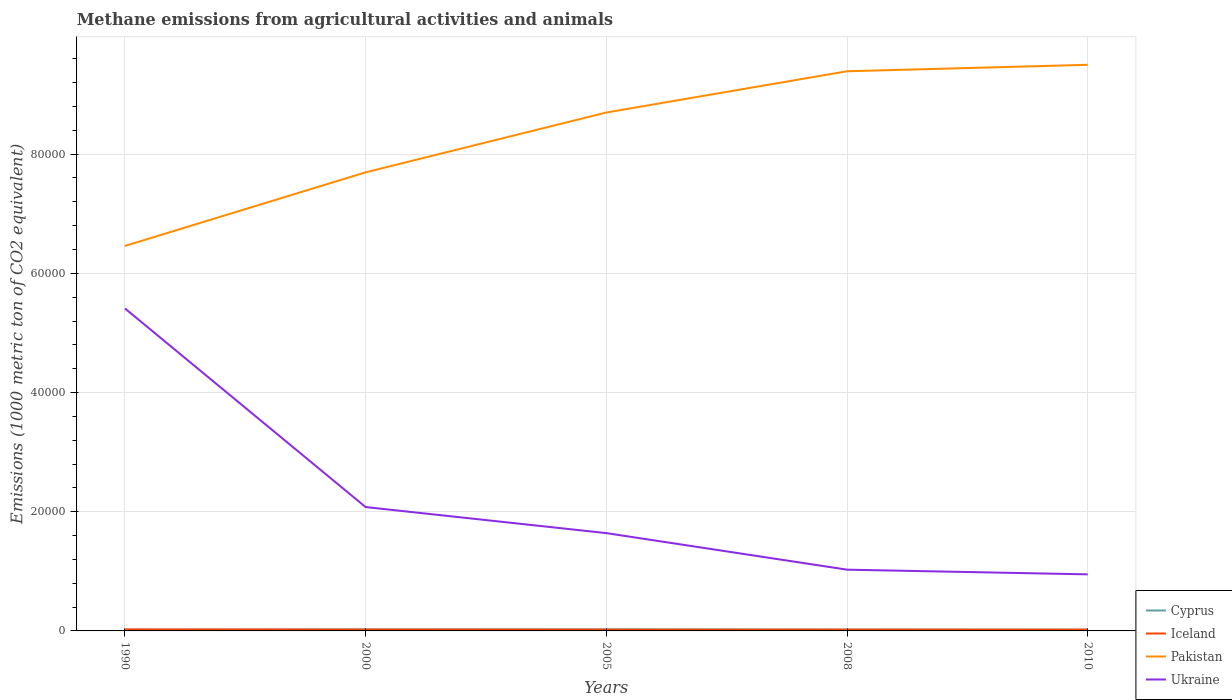How many different coloured lines are there?
Provide a succinct answer. 4. Does the line corresponding to Pakistan intersect with the line corresponding to Ukraine?
Offer a terse response. No. Is the number of lines equal to the number of legend labels?
Offer a terse response. Yes. Across all years, what is the maximum amount of methane emitted in Iceland?
Keep it short and to the point. 209.2. In which year was the amount of methane emitted in Cyprus maximum?
Offer a very short reply. 2010. What is the total amount of methane emitted in Ukraine in the graph?
Provide a short and direct response. 6921.6. What is the difference between the highest and the second highest amount of methane emitted in Iceland?
Your answer should be very brief. 36.1. What is the difference between the highest and the lowest amount of methane emitted in Cyprus?
Your response must be concise. 2. Is the amount of methane emitted in Pakistan strictly greater than the amount of methane emitted in Ukraine over the years?
Your response must be concise. No. What is the difference between two consecutive major ticks on the Y-axis?
Your response must be concise. 2.00e+04. Does the graph contain any zero values?
Ensure brevity in your answer.  No. Where does the legend appear in the graph?
Make the answer very short. Bottom right. How many legend labels are there?
Provide a succinct answer. 4. What is the title of the graph?
Your answer should be very brief. Methane emissions from agricultural activities and animals. What is the label or title of the X-axis?
Your answer should be very brief. Years. What is the label or title of the Y-axis?
Your response must be concise. Emissions (1000 metric ton of CO2 equivalent). What is the Emissions (1000 metric ton of CO2 equivalent) in Cyprus in 1990?
Offer a very short reply. 225.1. What is the Emissions (1000 metric ton of CO2 equivalent) in Iceland in 1990?
Your answer should be very brief. 245.3. What is the Emissions (1000 metric ton of CO2 equivalent) of Pakistan in 1990?
Ensure brevity in your answer.  6.46e+04. What is the Emissions (1000 metric ton of CO2 equivalent) in Ukraine in 1990?
Make the answer very short. 5.41e+04. What is the Emissions (1000 metric ton of CO2 equivalent) of Cyprus in 2000?
Ensure brevity in your answer.  261.7. What is the Emissions (1000 metric ton of CO2 equivalent) of Iceland in 2000?
Your response must be concise. 223.7. What is the Emissions (1000 metric ton of CO2 equivalent) of Pakistan in 2000?
Keep it short and to the point. 7.69e+04. What is the Emissions (1000 metric ton of CO2 equivalent) in Ukraine in 2000?
Provide a succinct answer. 2.08e+04. What is the Emissions (1000 metric ton of CO2 equivalent) of Cyprus in 2005?
Give a very brief answer. 271. What is the Emissions (1000 metric ton of CO2 equivalent) in Iceland in 2005?
Ensure brevity in your answer.  214.9. What is the Emissions (1000 metric ton of CO2 equivalent) of Pakistan in 2005?
Provide a succinct answer. 8.70e+04. What is the Emissions (1000 metric ton of CO2 equivalent) in Ukraine in 2005?
Your answer should be compact. 1.64e+04. What is the Emissions (1000 metric ton of CO2 equivalent) in Cyprus in 2008?
Offer a terse response. 231.7. What is the Emissions (1000 metric ton of CO2 equivalent) in Iceland in 2008?
Your response must be concise. 209.2. What is the Emissions (1000 metric ton of CO2 equivalent) of Pakistan in 2008?
Provide a short and direct response. 9.39e+04. What is the Emissions (1000 metric ton of CO2 equivalent) of Ukraine in 2008?
Your answer should be compact. 1.03e+04. What is the Emissions (1000 metric ton of CO2 equivalent) of Cyprus in 2010?
Offer a terse response. 217.6. What is the Emissions (1000 metric ton of CO2 equivalent) of Iceland in 2010?
Your answer should be compact. 212.4. What is the Emissions (1000 metric ton of CO2 equivalent) of Pakistan in 2010?
Offer a very short reply. 9.50e+04. What is the Emissions (1000 metric ton of CO2 equivalent) in Ukraine in 2010?
Your answer should be compact. 9489.8. Across all years, what is the maximum Emissions (1000 metric ton of CO2 equivalent) of Cyprus?
Provide a short and direct response. 271. Across all years, what is the maximum Emissions (1000 metric ton of CO2 equivalent) in Iceland?
Offer a very short reply. 245.3. Across all years, what is the maximum Emissions (1000 metric ton of CO2 equivalent) of Pakistan?
Offer a terse response. 9.50e+04. Across all years, what is the maximum Emissions (1000 metric ton of CO2 equivalent) of Ukraine?
Make the answer very short. 5.41e+04. Across all years, what is the minimum Emissions (1000 metric ton of CO2 equivalent) in Cyprus?
Your answer should be compact. 217.6. Across all years, what is the minimum Emissions (1000 metric ton of CO2 equivalent) in Iceland?
Make the answer very short. 209.2. Across all years, what is the minimum Emissions (1000 metric ton of CO2 equivalent) of Pakistan?
Make the answer very short. 6.46e+04. Across all years, what is the minimum Emissions (1000 metric ton of CO2 equivalent) of Ukraine?
Offer a very short reply. 9489.8. What is the total Emissions (1000 metric ton of CO2 equivalent) in Cyprus in the graph?
Your answer should be compact. 1207.1. What is the total Emissions (1000 metric ton of CO2 equivalent) in Iceland in the graph?
Give a very brief answer. 1105.5. What is the total Emissions (1000 metric ton of CO2 equivalent) of Pakistan in the graph?
Ensure brevity in your answer.  4.17e+05. What is the total Emissions (1000 metric ton of CO2 equivalent) of Ukraine in the graph?
Your answer should be very brief. 1.11e+05. What is the difference between the Emissions (1000 metric ton of CO2 equivalent) of Cyprus in 1990 and that in 2000?
Your answer should be compact. -36.6. What is the difference between the Emissions (1000 metric ton of CO2 equivalent) of Iceland in 1990 and that in 2000?
Offer a very short reply. 21.6. What is the difference between the Emissions (1000 metric ton of CO2 equivalent) in Pakistan in 1990 and that in 2000?
Provide a short and direct response. -1.24e+04. What is the difference between the Emissions (1000 metric ton of CO2 equivalent) in Ukraine in 1990 and that in 2000?
Offer a terse response. 3.33e+04. What is the difference between the Emissions (1000 metric ton of CO2 equivalent) of Cyprus in 1990 and that in 2005?
Offer a very short reply. -45.9. What is the difference between the Emissions (1000 metric ton of CO2 equivalent) in Iceland in 1990 and that in 2005?
Give a very brief answer. 30.4. What is the difference between the Emissions (1000 metric ton of CO2 equivalent) of Pakistan in 1990 and that in 2005?
Provide a short and direct response. -2.24e+04. What is the difference between the Emissions (1000 metric ton of CO2 equivalent) in Ukraine in 1990 and that in 2005?
Offer a very short reply. 3.77e+04. What is the difference between the Emissions (1000 metric ton of CO2 equivalent) of Cyprus in 1990 and that in 2008?
Offer a very short reply. -6.6. What is the difference between the Emissions (1000 metric ton of CO2 equivalent) in Iceland in 1990 and that in 2008?
Make the answer very short. 36.1. What is the difference between the Emissions (1000 metric ton of CO2 equivalent) of Pakistan in 1990 and that in 2008?
Provide a succinct answer. -2.93e+04. What is the difference between the Emissions (1000 metric ton of CO2 equivalent) of Ukraine in 1990 and that in 2008?
Keep it short and to the point. 4.38e+04. What is the difference between the Emissions (1000 metric ton of CO2 equivalent) in Iceland in 1990 and that in 2010?
Your response must be concise. 32.9. What is the difference between the Emissions (1000 metric ton of CO2 equivalent) in Pakistan in 1990 and that in 2010?
Provide a short and direct response. -3.04e+04. What is the difference between the Emissions (1000 metric ton of CO2 equivalent) of Ukraine in 1990 and that in 2010?
Offer a very short reply. 4.46e+04. What is the difference between the Emissions (1000 metric ton of CO2 equivalent) in Cyprus in 2000 and that in 2005?
Offer a terse response. -9.3. What is the difference between the Emissions (1000 metric ton of CO2 equivalent) of Iceland in 2000 and that in 2005?
Offer a very short reply. 8.8. What is the difference between the Emissions (1000 metric ton of CO2 equivalent) in Pakistan in 2000 and that in 2005?
Provide a short and direct response. -1.00e+04. What is the difference between the Emissions (1000 metric ton of CO2 equivalent) in Ukraine in 2000 and that in 2005?
Your answer should be very brief. 4372.1. What is the difference between the Emissions (1000 metric ton of CO2 equivalent) in Pakistan in 2000 and that in 2008?
Provide a succinct answer. -1.70e+04. What is the difference between the Emissions (1000 metric ton of CO2 equivalent) of Ukraine in 2000 and that in 2008?
Offer a terse response. 1.05e+04. What is the difference between the Emissions (1000 metric ton of CO2 equivalent) of Cyprus in 2000 and that in 2010?
Give a very brief answer. 44.1. What is the difference between the Emissions (1000 metric ton of CO2 equivalent) in Pakistan in 2000 and that in 2010?
Provide a short and direct response. -1.80e+04. What is the difference between the Emissions (1000 metric ton of CO2 equivalent) in Ukraine in 2000 and that in 2010?
Your answer should be compact. 1.13e+04. What is the difference between the Emissions (1000 metric ton of CO2 equivalent) of Cyprus in 2005 and that in 2008?
Keep it short and to the point. 39.3. What is the difference between the Emissions (1000 metric ton of CO2 equivalent) in Iceland in 2005 and that in 2008?
Offer a terse response. 5.7. What is the difference between the Emissions (1000 metric ton of CO2 equivalent) in Pakistan in 2005 and that in 2008?
Your answer should be compact. -6920.4. What is the difference between the Emissions (1000 metric ton of CO2 equivalent) of Ukraine in 2005 and that in 2008?
Your answer should be compact. 6133.4. What is the difference between the Emissions (1000 metric ton of CO2 equivalent) of Cyprus in 2005 and that in 2010?
Your answer should be very brief. 53.4. What is the difference between the Emissions (1000 metric ton of CO2 equivalent) in Iceland in 2005 and that in 2010?
Provide a short and direct response. 2.5. What is the difference between the Emissions (1000 metric ton of CO2 equivalent) of Pakistan in 2005 and that in 2010?
Give a very brief answer. -8002.4. What is the difference between the Emissions (1000 metric ton of CO2 equivalent) of Ukraine in 2005 and that in 2010?
Ensure brevity in your answer.  6921.6. What is the difference between the Emissions (1000 metric ton of CO2 equivalent) in Pakistan in 2008 and that in 2010?
Offer a very short reply. -1082. What is the difference between the Emissions (1000 metric ton of CO2 equivalent) of Ukraine in 2008 and that in 2010?
Offer a terse response. 788.2. What is the difference between the Emissions (1000 metric ton of CO2 equivalent) of Cyprus in 1990 and the Emissions (1000 metric ton of CO2 equivalent) of Pakistan in 2000?
Ensure brevity in your answer.  -7.67e+04. What is the difference between the Emissions (1000 metric ton of CO2 equivalent) of Cyprus in 1990 and the Emissions (1000 metric ton of CO2 equivalent) of Ukraine in 2000?
Offer a terse response. -2.06e+04. What is the difference between the Emissions (1000 metric ton of CO2 equivalent) in Iceland in 1990 and the Emissions (1000 metric ton of CO2 equivalent) in Pakistan in 2000?
Your answer should be compact. -7.67e+04. What is the difference between the Emissions (1000 metric ton of CO2 equivalent) in Iceland in 1990 and the Emissions (1000 metric ton of CO2 equivalent) in Ukraine in 2000?
Your answer should be compact. -2.05e+04. What is the difference between the Emissions (1000 metric ton of CO2 equivalent) in Pakistan in 1990 and the Emissions (1000 metric ton of CO2 equivalent) in Ukraine in 2000?
Give a very brief answer. 4.38e+04. What is the difference between the Emissions (1000 metric ton of CO2 equivalent) of Cyprus in 1990 and the Emissions (1000 metric ton of CO2 equivalent) of Pakistan in 2005?
Offer a very short reply. -8.68e+04. What is the difference between the Emissions (1000 metric ton of CO2 equivalent) of Cyprus in 1990 and the Emissions (1000 metric ton of CO2 equivalent) of Ukraine in 2005?
Your answer should be very brief. -1.62e+04. What is the difference between the Emissions (1000 metric ton of CO2 equivalent) of Iceland in 1990 and the Emissions (1000 metric ton of CO2 equivalent) of Pakistan in 2005?
Provide a short and direct response. -8.67e+04. What is the difference between the Emissions (1000 metric ton of CO2 equivalent) of Iceland in 1990 and the Emissions (1000 metric ton of CO2 equivalent) of Ukraine in 2005?
Give a very brief answer. -1.62e+04. What is the difference between the Emissions (1000 metric ton of CO2 equivalent) of Pakistan in 1990 and the Emissions (1000 metric ton of CO2 equivalent) of Ukraine in 2005?
Give a very brief answer. 4.82e+04. What is the difference between the Emissions (1000 metric ton of CO2 equivalent) in Cyprus in 1990 and the Emissions (1000 metric ton of CO2 equivalent) in Pakistan in 2008?
Your answer should be compact. -9.37e+04. What is the difference between the Emissions (1000 metric ton of CO2 equivalent) of Cyprus in 1990 and the Emissions (1000 metric ton of CO2 equivalent) of Ukraine in 2008?
Provide a succinct answer. -1.01e+04. What is the difference between the Emissions (1000 metric ton of CO2 equivalent) of Iceland in 1990 and the Emissions (1000 metric ton of CO2 equivalent) of Pakistan in 2008?
Your response must be concise. -9.37e+04. What is the difference between the Emissions (1000 metric ton of CO2 equivalent) in Iceland in 1990 and the Emissions (1000 metric ton of CO2 equivalent) in Ukraine in 2008?
Keep it short and to the point. -1.00e+04. What is the difference between the Emissions (1000 metric ton of CO2 equivalent) of Pakistan in 1990 and the Emissions (1000 metric ton of CO2 equivalent) of Ukraine in 2008?
Ensure brevity in your answer.  5.43e+04. What is the difference between the Emissions (1000 metric ton of CO2 equivalent) of Cyprus in 1990 and the Emissions (1000 metric ton of CO2 equivalent) of Iceland in 2010?
Your response must be concise. 12.7. What is the difference between the Emissions (1000 metric ton of CO2 equivalent) in Cyprus in 1990 and the Emissions (1000 metric ton of CO2 equivalent) in Pakistan in 2010?
Keep it short and to the point. -9.48e+04. What is the difference between the Emissions (1000 metric ton of CO2 equivalent) of Cyprus in 1990 and the Emissions (1000 metric ton of CO2 equivalent) of Ukraine in 2010?
Your response must be concise. -9264.7. What is the difference between the Emissions (1000 metric ton of CO2 equivalent) of Iceland in 1990 and the Emissions (1000 metric ton of CO2 equivalent) of Pakistan in 2010?
Make the answer very short. -9.47e+04. What is the difference between the Emissions (1000 metric ton of CO2 equivalent) in Iceland in 1990 and the Emissions (1000 metric ton of CO2 equivalent) in Ukraine in 2010?
Keep it short and to the point. -9244.5. What is the difference between the Emissions (1000 metric ton of CO2 equivalent) in Pakistan in 1990 and the Emissions (1000 metric ton of CO2 equivalent) in Ukraine in 2010?
Your answer should be very brief. 5.51e+04. What is the difference between the Emissions (1000 metric ton of CO2 equivalent) in Cyprus in 2000 and the Emissions (1000 metric ton of CO2 equivalent) in Iceland in 2005?
Provide a short and direct response. 46.8. What is the difference between the Emissions (1000 metric ton of CO2 equivalent) in Cyprus in 2000 and the Emissions (1000 metric ton of CO2 equivalent) in Pakistan in 2005?
Offer a terse response. -8.67e+04. What is the difference between the Emissions (1000 metric ton of CO2 equivalent) of Cyprus in 2000 and the Emissions (1000 metric ton of CO2 equivalent) of Ukraine in 2005?
Provide a succinct answer. -1.61e+04. What is the difference between the Emissions (1000 metric ton of CO2 equivalent) of Iceland in 2000 and the Emissions (1000 metric ton of CO2 equivalent) of Pakistan in 2005?
Keep it short and to the point. -8.68e+04. What is the difference between the Emissions (1000 metric ton of CO2 equivalent) in Iceland in 2000 and the Emissions (1000 metric ton of CO2 equivalent) in Ukraine in 2005?
Provide a succinct answer. -1.62e+04. What is the difference between the Emissions (1000 metric ton of CO2 equivalent) of Pakistan in 2000 and the Emissions (1000 metric ton of CO2 equivalent) of Ukraine in 2005?
Give a very brief answer. 6.05e+04. What is the difference between the Emissions (1000 metric ton of CO2 equivalent) of Cyprus in 2000 and the Emissions (1000 metric ton of CO2 equivalent) of Iceland in 2008?
Offer a very short reply. 52.5. What is the difference between the Emissions (1000 metric ton of CO2 equivalent) in Cyprus in 2000 and the Emissions (1000 metric ton of CO2 equivalent) in Pakistan in 2008?
Keep it short and to the point. -9.36e+04. What is the difference between the Emissions (1000 metric ton of CO2 equivalent) in Cyprus in 2000 and the Emissions (1000 metric ton of CO2 equivalent) in Ukraine in 2008?
Offer a very short reply. -1.00e+04. What is the difference between the Emissions (1000 metric ton of CO2 equivalent) of Iceland in 2000 and the Emissions (1000 metric ton of CO2 equivalent) of Pakistan in 2008?
Your answer should be compact. -9.37e+04. What is the difference between the Emissions (1000 metric ton of CO2 equivalent) of Iceland in 2000 and the Emissions (1000 metric ton of CO2 equivalent) of Ukraine in 2008?
Your answer should be compact. -1.01e+04. What is the difference between the Emissions (1000 metric ton of CO2 equivalent) of Pakistan in 2000 and the Emissions (1000 metric ton of CO2 equivalent) of Ukraine in 2008?
Keep it short and to the point. 6.67e+04. What is the difference between the Emissions (1000 metric ton of CO2 equivalent) of Cyprus in 2000 and the Emissions (1000 metric ton of CO2 equivalent) of Iceland in 2010?
Your answer should be compact. 49.3. What is the difference between the Emissions (1000 metric ton of CO2 equivalent) in Cyprus in 2000 and the Emissions (1000 metric ton of CO2 equivalent) in Pakistan in 2010?
Keep it short and to the point. -9.47e+04. What is the difference between the Emissions (1000 metric ton of CO2 equivalent) in Cyprus in 2000 and the Emissions (1000 metric ton of CO2 equivalent) in Ukraine in 2010?
Your answer should be compact. -9228.1. What is the difference between the Emissions (1000 metric ton of CO2 equivalent) in Iceland in 2000 and the Emissions (1000 metric ton of CO2 equivalent) in Pakistan in 2010?
Keep it short and to the point. -9.48e+04. What is the difference between the Emissions (1000 metric ton of CO2 equivalent) in Iceland in 2000 and the Emissions (1000 metric ton of CO2 equivalent) in Ukraine in 2010?
Provide a succinct answer. -9266.1. What is the difference between the Emissions (1000 metric ton of CO2 equivalent) of Pakistan in 2000 and the Emissions (1000 metric ton of CO2 equivalent) of Ukraine in 2010?
Your answer should be compact. 6.75e+04. What is the difference between the Emissions (1000 metric ton of CO2 equivalent) of Cyprus in 2005 and the Emissions (1000 metric ton of CO2 equivalent) of Iceland in 2008?
Offer a terse response. 61.8. What is the difference between the Emissions (1000 metric ton of CO2 equivalent) in Cyprus in 2005 and the Emissions (1000 metric ton of CO2 equivalent) in Pakistan in 2008?
Your response must be concise. -9.36e+04. What is the difference between the Emissions (1000 metric ton of CO2 equivalent) in Cyprus in 2005 and the Emissions (1000 metric ton of CO2 equivalent) in Ukraine in 2008?
Your answer should be compact. -1.00e+04. What is the difference between the Emissions (1000 metric ton of CO2 equivalent) of Iceland in 2005 and the Emissions (1000 metric ton of CO2 equivalent) of Pakistan in 2008?
Keep it short and to the point. -9.37e+04. What is the difference between the Emissions (1000 metric ton of CO2 equivalent) of Iceland in 2005 and the Emissions (1000 metric ton of CO2 equivalent) of Ukraine in 2008?
Provide a short and direct response. -1.01e+04. What is the difference between the Emissions (1000 metric ton of CO2 equivalent) of Pakistan in 2005 and the Emissions (1000 metric ton of CO2 equivalent) of Ukraine in 2008?
Offer a very short reply. 7.67e+04. What is the difference between the Emissions (1000 metric ton of CO2 equivalent) of Cyprus in 2005 and the Emissions (1000 metric ton of CO2 equivalent) of Iceland in 2010?
Your response must be concise. 58.6. What is the difference between the Emissions (1000 metric ton of CO2 equivalent) of Cyprus in 2005 and the Emissions (1000 metric ton of CO2 equivalent) of Pakistan in 2010?
Offer a terse response. -9.47e+04. What is the difference between the Emissions (1000 metric ton of CO2 equivalent) in Cyprus in 2005 and the Emissions (1000 metric ton of CO2 equivalent) in Ukraine in 2010?
Your answer should be very brief. -9218.8. What is the difference between the Emissions (1000 metric ton of CO2 equivalent) in Iceland in 2005 and the Emissions (1000 metric ton of CO2 equivalent) in Pakistan in 2010?
Provide a succinct answer. -9.48e+04. What is the difference between the Emissions (1000 metric ton of CO2 equivalent) in Iceland in 2005 and the Emissions (1000 metric ton of CO2 equivalent) in Ukraine in 2010?
Your response must be concise. -9274.9. What is the difference between the Emissions (1000 metric ton of CO2 equivalent) in Pakistan in 2005 and the Emissions (1000 metric ton of CO2 equivalent) in Ukraine in 2010?
Offer a terse response. 7.75e+04. What is the difference between the Emissions (1000 metric ton of CO2 equivalent) of Cyprus in 2008 and the Emissions (1000 metric ton of CO2 equivalent) of Iceland in 2010?
Keep it short and to the point. 19.3. What is the difference between the Emissions (1000 metric ton of CO2 equivalent) of Cyprus in 2008 and the Emissions (1000 metric ton of CO2 equivalent) of Pakistan in 2010?
Keep it short and to the point. -9.48e+04. What is the difference between the Emissions (1000 metric ton of CO2 equivalent) of Cyprus in 2008 and the Emissions (1000 metric ton of CO2 equivalent) of Ukraine in 2010?
Provide a short and direct response. -9258.1. What is the difference between the Emissions (1000 metric ton of CO2 equivalent) in Iceland in 2008 and the Emissions (1000 metric ton of CO2 equivalent) in Pakistan in 2010?
Offer a terse response. -9.48e+04. What is the difference between the Emissions (1000 metric ton of CO2 equivalent) of Iceland in 2008 and the Emissions (1000 metric ton of CO2 equivalent) of Ukraine in 2010?
Ensure brevity in your answer.  -9280.6. What is the difference between the Emissions (1000 metric ton of CO2 equivalent) in Pakistan in 2008 and the Emissions (1000 metric ton of CO2 equivalent) in Ukraine in 2010?
Give a very brief answer. 8.44e+04. What is the average Emissions (1000 metric ton of CO2 equivalent) of Cyprus per year?
Ensure brevity in your answer.  241.42. What is the average Emissions (1000 metric ton of CO2 equivalent) in Iceland per year?
Provide a short and direct response. 221.1. What is the average Emissions (1000 metric ton of CO2 equivalent) of Pakistan per year?
Offer a terse response. 8.35e+04. What is the average Emissions (1000 metric ton of CO2 equivalent) of Ukraine per year?
Your response must be concise. 2.22e+04. In the year 1990, what is the difference between the Emissions (1000 metric ton of CO2 equivalent) of Cyprus and Emissions (1000 metric ton of CO2 equivalent) of Iceland?
Your answer should be very brief. -20.2. In the year 1990, what is the difference between the Emissions (1000 metric ton of CO2 equivalent) in Cyprus and Emissions (1000 metric ton of CO2 equivalent) in Pakistan?
Offer a very short reply. -6.44e+04. In the year 1990, what is the difference between the Emissions (1000 metric ton of CO2 equivalent) of Cyprus and Emissions (1000 metric ton of CO2 equivalent) of Ukraine?
Keep it short and to the point. -5.39e+04. In the year 1990, what is the difference between the Emissions (1000 metric ton of CO2 equivalent) in Iceland and Emissions (1000 metric ton of CO2 equivalent) in Pakistan?
Your answer should be very brief. -6.43e+04. In the year 1990, what is the difference between the Emissions (1000 metric ton of CO2 equivalent) of Iceland and Emissions (1000 metric ton of CO2 equivalent) of Ukraine?
Give a very brief answer. -5.39e+04. In the year 1990, what is the difference between the Emissions (1000 metric ton of CO2 equivalent) of Pakistan and Emissions (1000 metric ton of CO2 equivalent) of Ukraine?
Provide a short and direct response. 1.05e+04. In the year 2000, what is the difference between the Emissions (1000 metric ton of CO2 equivalent) of Cyprus and Emissions (1000 metric ton of CO2 equivalent) of Pakistan?
Ensure brevity in your answer.  -7.67e+04. In the year 2000, what is the difference between the Emissions (1000 metric ton of CO2 equivalent) of Cyprus and Emissions (1000 metric ton of CO2 equivalent) of Ukraine?
Provide a short and direct response. -2.05e+04. In the year 2000, what is the difference between the Emissions (1000 metric ton of CO2 equivalent) of Iceland and Emissions (1000 metric ton of CO2 equivalent) of Pakistan?
Offer a terse response. -7.67e+04. In the year 2000, what is the difference between the Emissions (1000 metric ton of CO2 equivalent) of Iceland and Emissions (1000 metric ton of CO2 equivalent) of Ukraine?
Offer a terse response. -2.06e+04. In the year 2000, what is the difference between the Emissions (1000 metric ton of CO2 equivalent) in Pakistan and Emissions (1000 metric ton of CO2 equivalent) in Ukraine?
Keep it short and to the point. 5.62e+04. In the year 2005, what is the difference between the Emissions (1000 metric ton of CO2 equivalent) in Cyprus and Emissions (1000 metric ton of CO2 equivalent) in Iceland?
Give a very brief answer. 56.1. In the year 2005, what is the difference between the Emissions (1000 metric ton of CO2 equivalent) of Cyprus and Emissions (1000 metric ton of CO2 equivalent) of Pakistan?
Ensure brevity in your answer.  -8.67e+04. In the year 2005, what is the difference between the Emissions (1000 metric ton of CO2 equivalent) in Cyprus and Emissions (1000 metric ton of CO2 equivalent) in Ukraine?
Provide a succinct answer. -1.61e+04. In the year 2005, what is the difference between the Emissions (1000 metric ton of CO2 equivalent) of Iceland and Emissions (1000 metric ton of CO2 equivalent) of Pakistan?
Ensure brevity in your answer.  -8.68e+04. In the year 2005, what is the difference between the Emissions (1000 metric ton of CO2 equivalent) in Iceland and Emissions (1000 metric ton of CO2 equivalent) in Ukraine?
Your response must be concise. -1.62e+04. In the year 2005, what is the difference between the Emissions (1000 metric ton of CO2 equivalent) in Pakistan and Emissions (1000 metric ton of CO2 equivalent) in Ukraine?
Make the answer very short. 7.06e+04. In the year 2008, what is the difference between the Emissions (1000 metric ton of CO2 equivalent) of Cyprus and Emissions (1000 metric ton of CO2 equivalent) of Pakistan?
Keep it short and to the point. -9.37e+04. In the year 2008, what is the difference between the Emissions (1000 metric ton of CO2 equivalent) of Cyprus and Emissions (1000 metric ton of CO2 equivalent) of Ukraine?
Keep it short and to the point. -1.00e+04. In the year 2008, what is the difference between the Emissions (1000 metric ton of CO2 equivalent) of Iceland and Emissions (1000 metric ton of CO2 equivalent) of Pakistan?
Offer a very short reply. -9.37e+04. In the year 2008, what is the difference between the Emissions (1000 metric ton of CO2 equivalent) of Iceland and Emissions (1000 metric ton of CO2 equivalent) of Ukraine?
Make the answer very short. -1.01e+04. In the year 2008, what is the difference between the Emissions (1000 metric ton of CO2 equivalent) in Pakistan and Emissions (1000 metric ton of CO2 equivalent) in Ukraine?
Make the answer very short. 8.36e+04. In the year 2010, what is the difference between the Emissions (1000 metric ton of CO2 equivalent) of Cyprus and Emissions (1000 metric ton of CO2 equivalent) of Pakistan?
Your answer should be compact. -9.48e+04. In the year 2010, what is the difference between the Emissions (1000 metric ton of CO2 equivalent) of Cyprus and Emissions (1000 metric ton of CO2 equivalent) of Ukraine?
Provide a short and direct response. -9272.2. In the year 2010, what is the difference between the Emissions (1000 metric ton of CO2 equivalent) of Iceland and Emissions (1000 metric ton of CO2 equivalent) of Pakistan?
Provide a succinct answer. -9.48e+04. In the year 2010, what is the difference between the Emissions (1000 metric ton of CO2 equivalent) in Iceland and Emissions (1000 metric ton of CO2 equivalent) in Ukraine?
Ensure brevity in your answer.  -9277.4. In the year 2010, what is the difference between the Emissions (1000 metric ton of CO2 equivalent) of Pakistan and Emissions (1000 metric ton of CO2 equivalent) of Ukraine?
Offer a terse response. 8.55e+04. What is the ratio of the Emissions (1000 metric ton of CO2 equivalent) of Cyprus in 1990 to that in 2000?
Keep it short and to the point. 0.86. What is the ratio of the Emissions (1000 metric ton of CO2 equivalent) in Iceland in 1990 to that in 2000?
Give a very brief answer. 1.1. What is the ratio of the Emissions (1000 metric ton of CO2 equivalent) in Pakistan in 1990 to that in 2000?
Your answer should be very brief. 0.84. What is the ratio of the Emissions (1000 metric ton of CO2 equivalent) of Ukraine in 1990 to that in 2000?
Keep it short and to the point. 2.6. What is the ratio of the Emissions (1000 metric ton of CO2 equivalent) of Cyprus in 1990 to that in 2005?
Offer a very short reply. 0.83. What is the ratio of the Emissions (1000 metric ton of CO2 equivalent) in Iceland in 1990 to that in 2005?
Keep it short and to the point. 1.14. What is the ratio of the Emissions (1000 metric ton of CO2 equivalent) in Pakistan in 1990 to that in 2005?
Your response must be concise. 0.74. What is the ratio of the Emissions (1000 metric ton of CO2 equivalent) in Ukraine in 1990 to that in 2005?
Offer a terse response. 3.3. What is the ratio of the Emissions (1000 metric ton of CO2 equivalent) of Cyprus in 1990 to that in 2008?
Ensure brevity in your answer.  0.97. What is the ratio of the Emissions (1000 metric ton of CO2 equivalent) in Iceland in 1990 to that in 2008?
Your answer should be very brief. 1.17. What is the ratio of the Emissions (1000 metric ton of CO2 equivalent) in Pakistan in 1990 to that in 2008?
Offer a very short reply. 0.69. What is the ratio of the Emissions (1000 metric ton of CO2 equivalent) in Ukraine in 1990 to that in 2008?
Give a very brief answer. 5.27. What is the ratio of the Emissions (1000 metric ton of CO2 equivalent) in Cyprus in 1990 to that in 2010?
Keep it short and to the point. 1.03. What is the ratio of the Emissions (1000 metric ton of CO2 equivalent) of Iceland in 1990 to that in 2010?
Make the answer very short. 1.15. What is the ratio of the Emissions (1000 metric ton of CO2 equivalent) of Pakistan in 1990 to that in 2010?
Ensure brevity in your answer.  0.68. What is the ratio of the Emissions (1000 metric ton of CO2 equivalent) of Ukraine in 1990 to that in 2010?
Ensure brevity in your answer.  5.7. What is the ratio of the Emissions (1000 metric ton of CO2 equivalent) of Cyprus in 2000 to that in 2005?
Provide a short and direct response. 0.97. What is the ratio of the Emissions (1000 metric ton of CO2 equivalent) in Iceland in 2000 to that in 2005?
Provide a short and direct response. 1.04. What is the ratio of the Emissions (1000 metric ton of CO2 equivalent) in Pakistan in 2000 to that in 2005?
Provide a succinct answer. 0.88. What is the ratio of the Emissions (1000 metric ton of CO2 equivalent) of Ukraine in 2000 to that in 2005?
Your answer should be very brief. 1.27. What is the ratio of the Emissions (1000 metric ton of CO2 equivalent) in Cyprus in 2000 to that in 2008?
Make the answer very short. 1.13. What is the ratio of the Emissions (1000 metric ton of CO2 equivalent) of Iceland in 2000 to that in 2008?
Provide a short and direct response. 1.07. What is the ratio of the Emissions (1000 metric ton of CO2 equivalent) in Pakistan in 2000 to that in 2008?
Your answer should be compact. 0.82. What is the ratio of the Emissions (1000 metric ton of CO2 equivalent) of Ukraine in 2000 to that in 2008?
Your response must be concise. 2.02. What is the ratio of the Emissions (1000 metric ton of CO2 equivalent) of Cyprus in 2000 to that in 2010?
Your response must be concise. 1.2. What is the ratio of the Emissions (1000 metric ton of CO2 equivalent) in Iceland in 2000 to that in 2010?
Offer a terse response. 1.05. What is the ratio of the Emissions (1000 metric ton of CO2 equivalent) of Pakistan in 2000 to that in 2010?
Ensure brevity in your answer.  0.81. What is the ratio of the Emissions (1000 metric ton of CO2 equivalent) in Ukraine in 2000 to that in 2010?
Provide a succinct answer. 2.19. What is the ratio of the Emissions (1000 metric ton of CO2 equivalent) in Cyprus in 2005 to that in 2008?
Provide a short and direct response. 1.17. What is the ratio of the Emissions (1000 metric ton of CO2 equivalent) in Iceland in 2005 to that in 2008?
Provide a short and direct response. 1.03. What is the ratio of the Emissions (1000 metric ton of CO2 equivalent) in Pakistan in 2005 to that in 2008?
Your answer should be very brief. 0.93. What is the ratio of the Emissions (1000 metric ton of CO2 equivalent) of Ukraine in 2005 to that in 2008?
Offer a very short reply. 1.6. What is the ratio of the Emissions (1000 metric ton of CO2 equivalent) of Cyprus in 2005 to that in 2010?
Offer a very short reply. 1.25. What is the ratio of the Emissions (1000 metric ton of CO2 equivalent) in Iceland in 2005 to that in 2010?
Provide a succinct answer. 1.01. What is the ratio of the Emissions (1000 metric ton of CO2 equivalent) in Pakistan in 2005 to that in 2010?
Ensure brevity in your answer.  0.92. What is the ratio of the Emissions (1000 metric ton of CO2 equivalent) of Ukraine in 2005 to that in 2010?
Ensure brevity in your answer.  1.73. What is the ratio of the Emissions (1000 metric ton of CO2 equivalent) in Cyprus in 2008 to that in 2010?
Your answer should be very brief. 1.06. What is the ratio of the Emissions (1000 metric ton of CO2 equivalent) of Iceland in 2008 to that in 2010?
Your response must be concise. 0.98. What is the ratio of the Emissions (1000 metric ton of CO2 equivalent) in Pakistan in 2008 to that in 2010?
Offer a very short reply. 0.99. What is the ratio of the Emissions (1000 metric ton of CO2 equivalent) of Ukraine in 2008 to that in 2010?
Keep it short and to the point. 1.08. What is the difference between the highest and the second highest Emissions (1000 metric ton of CO2 equivalent) of Iceland?
Provide a succinct answer. 21.6. What is the difference between the highest and the second highest Emissions (1000 metric ton of CO2 equivalent) in Pakistan?
Provide a short and direct response. 1082. What is the difference between the highest and the second highest Emissions (1000 metric ton of CO2 equivalent) in Ukraine?
Keep it short and to the point. 3.33e+04. What is the difference between the highest and the lowest Emissions (1000 metric ton of CO2 equivalent) in Cyprus?
Offer a very short reply. 53.4. What is the difference between the highest and the lowest Emissions (1000 metric ton of CO2 equivalent) of Iceland?
Offer a terse response. 36.1. What is the difference between the highest and the lowest Emissions (1000 metric ton of CO2 equivalent) of Pakistan?
Ensure brevity in your answer.  3.04e+04. What is the difference between the highest and the lowest Emissions (1000 metric ton of CO2 equivalent) of Ukraine?
Make the answer very short. 4.46e+04. 